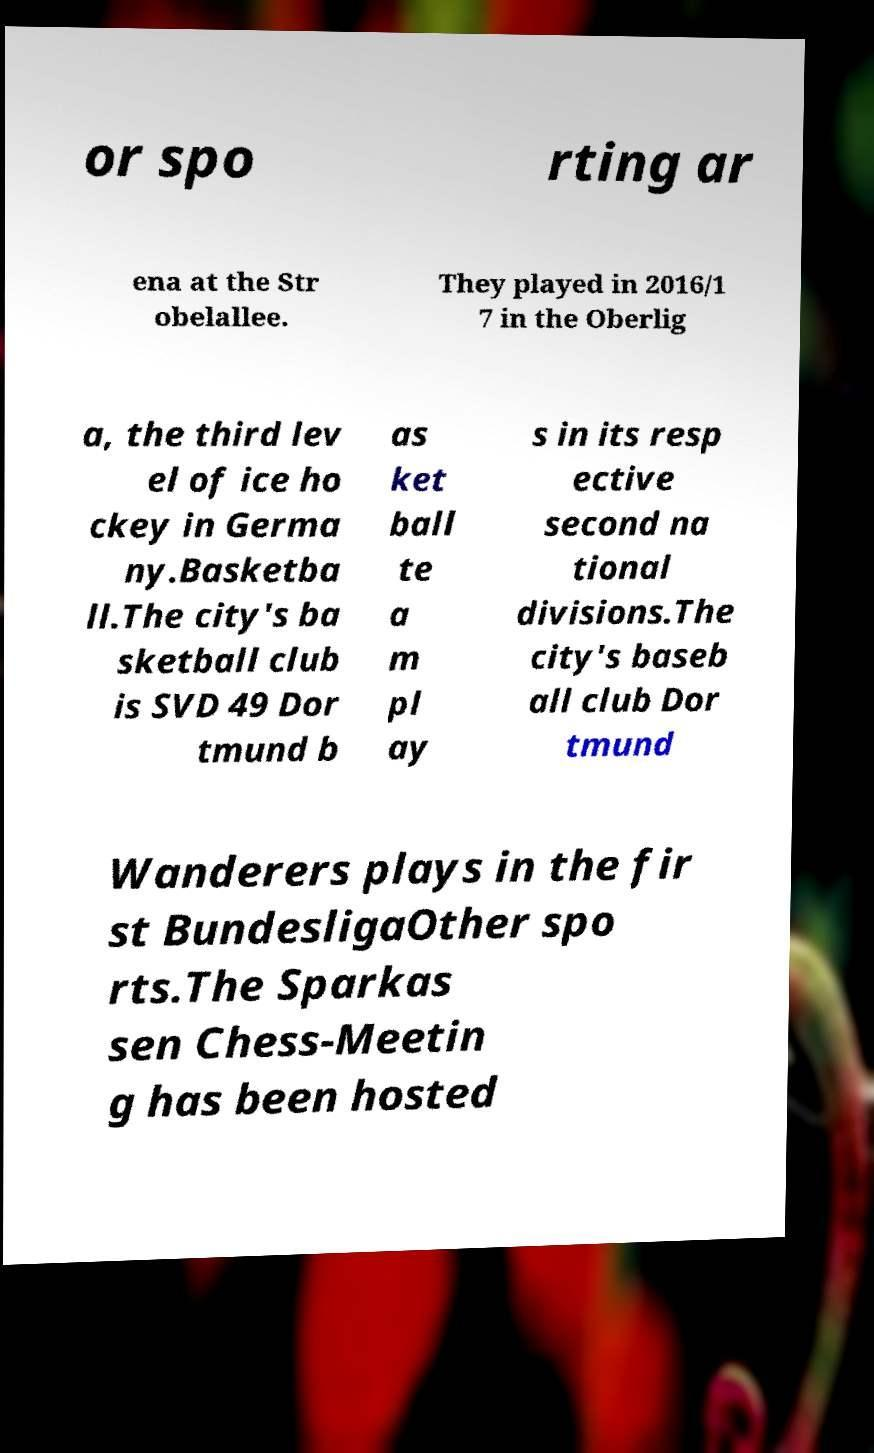Please identify and transcribe the text found in this image. or spo rting ar ena at the Str obelallee. They played in 2016/1 7 in the Oberlig a, the third lev el of ice ho ckey in Germa ny.Basketba ll.The city's ba sketball club is SVD 49 Dor tmund b as ket ball te a m pl ay s in its resp ective second na tional divisions.The city's baseb all club Dor tmund Wanderers plays in the fir st BundesligaOther spo rts.The Sparkas sen Chess-Meetin g has been hosted 